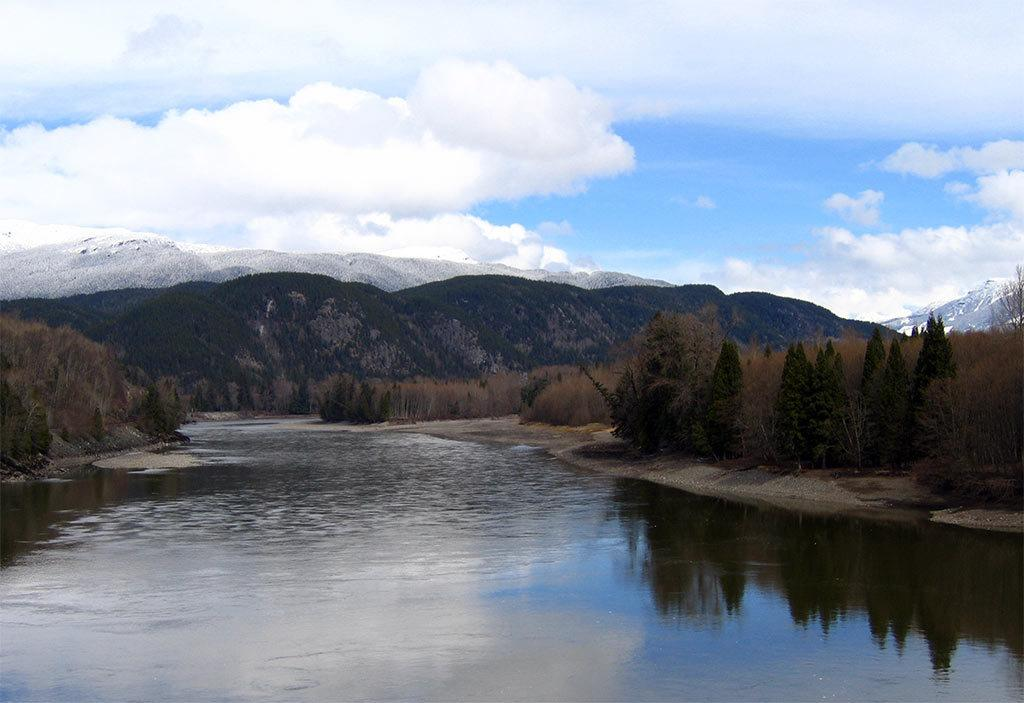What type of natural environment is depicted in the image? The image features water, trees, and hills covered with snow, suggesting a winter landscape. What is visible on the ground in the image? The ground is visible in the image, and it appears to be covered with snow. What type of vegetation can be seen in the image? There are trees and dried plants visible in the image. What is visible in the sky in the image? The sky is visible in the image, and clouds are present. What type of liquid can be heard splashing in the image? There is no liquid present in the image, and therefore no splashing sound can be heard. What type of voice can be heard singing in the image? There is no voice or singing present in the image. 